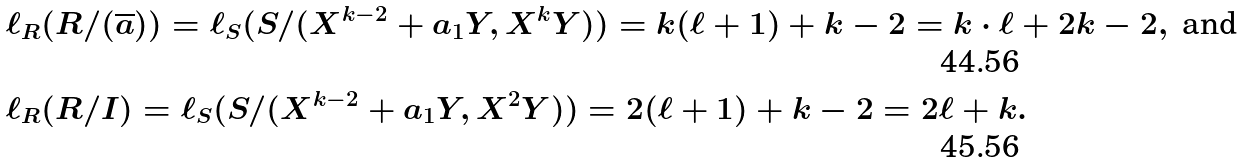Convert formula to latex. <formula><loc_0><loc_0><loc_500><loc_500>& \ell _ { R } ( R / ( \overline { a } ) ) = \ell _ { S } ( S / ( X ^ { k - 2 } + a _ { 1 } Y , X ^ { k } Y ) ) = k ( \ell + 1 ) + k - 2 = k \cdot \ell + 2 k - 2 , \ \text {and} \\ & \ell _ { R } ( R / I ) = \ell _ { S } ( S / ( X ^ { k - 2 } + a _ { 1 } Y , X ^ { 2 } Y ) ) = 2 ( \ell + 1 ) + k - 2 = 2 \ell + k .</formula> 